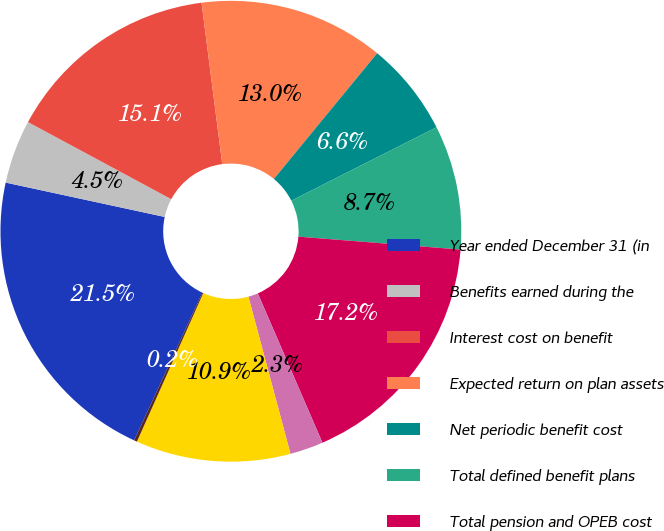Convert chart to OTSL. <chart><loc_0><loc_0><loc_500><loc_500><pie_chart><fcel>Year ended December 31 (in<fcel>Benefits earned during the<fcel>Interest cost on benefit<fcel>Expected return on plan assets<fcel>Net periodic benefit cost<fcel>Total defined benefit plans<fcel>Total pension and OPEB cost<fcel>Net (gain)/loss arising during<fcel>Total recognized in other<fcel>Total recognized in net<nl><fcel>21.49%<fcel>4.47%<fcel>15.11%<fcel>12.98%<fcel>6.6%<fcel>8.72%<fcel>17.23%<fcel>2.34%<fcel>10.85%<fcel>0.21%<nl></chart> 